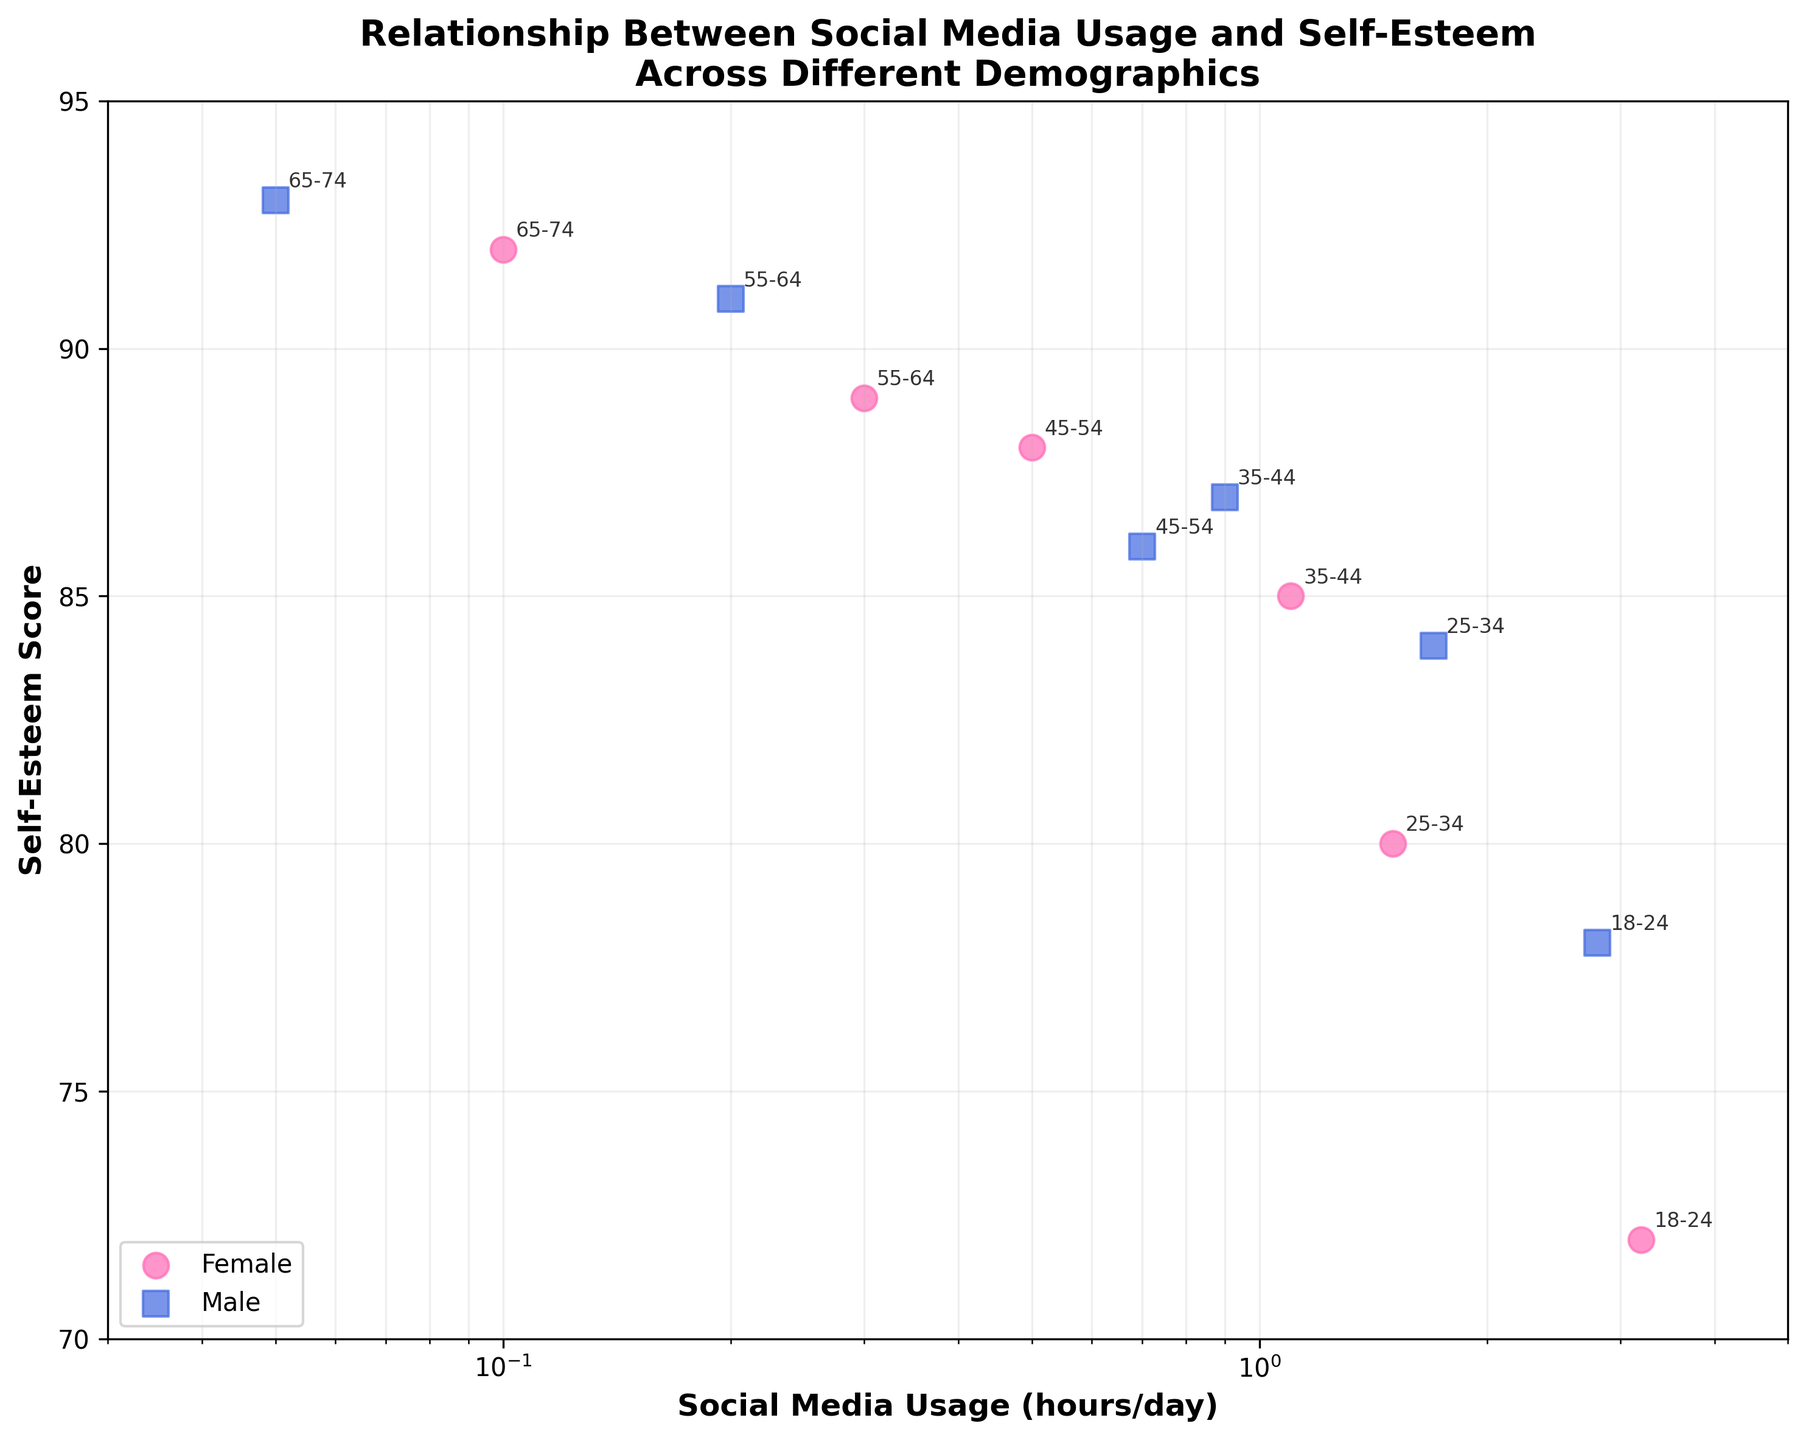What is the title of the plot? The title of the plot is written at the top, summarizing the overall content of the figure. In this case, it is stated clearly.
Answer: Relationship Between Social Media Usage and Self-Esteem Across Different Demographics What type of scale is used on the x-axis? The x-axis uses a log scale, which is indicated by the axis label and the spacing of the tick marks.
Answer: Log scale How many data points are there for the female demographic? The plot uses color and marker shapes to distinguish between genders. The pink circles represent females. There are 6 such data points.
Answer: 6 Which age group has the highest self-esteem score? By looking at the annotated age groups, the data point with the highest y-value represents the highest self-esteem score. The age group is 65-74 with a score of 93 (male).
Answer: 65-74 Comparing males and females in the 18-24 age group, who has higher self-esteem? By looking at the annotations for the 18-24 age group, we can observe the y-values. The male (blue square) has a higher self-esteem score of 78 compared to the female's 72.
Answer: Male What is the average self-esteem score for the 25-34 age group? There are two data points for the 25-34 age group: females with a score of 80 and males with a score of 84. The average is calculated as (80 + 84) / 2.
Answer: 82 How does social media usage correlate with self-esteem among males? Observing the trend of blue squares, as social media usage decreases (moving left on the x-axis), self-esteem scores increase (moving up on the y-axis). This suggests a negative correlation.
Answer: Negative correlation What is the difference in social media usage between the 18-24 female and 45-54 male groups? By identifying the respective points, the 18-24 female uses social media for 3.2 hours, while the 45-54 male uses it for 0.7 hours. The difference is 3.2 - 0.7.
Answer: 2.5 hours Which gender generally uses social media more across all age groups? By comparing the positions of pink circles and blue squares along the x-axis (log scale), females (pink circles) generally appear more to the right, indicating higher social media usage.
Answer: Females 